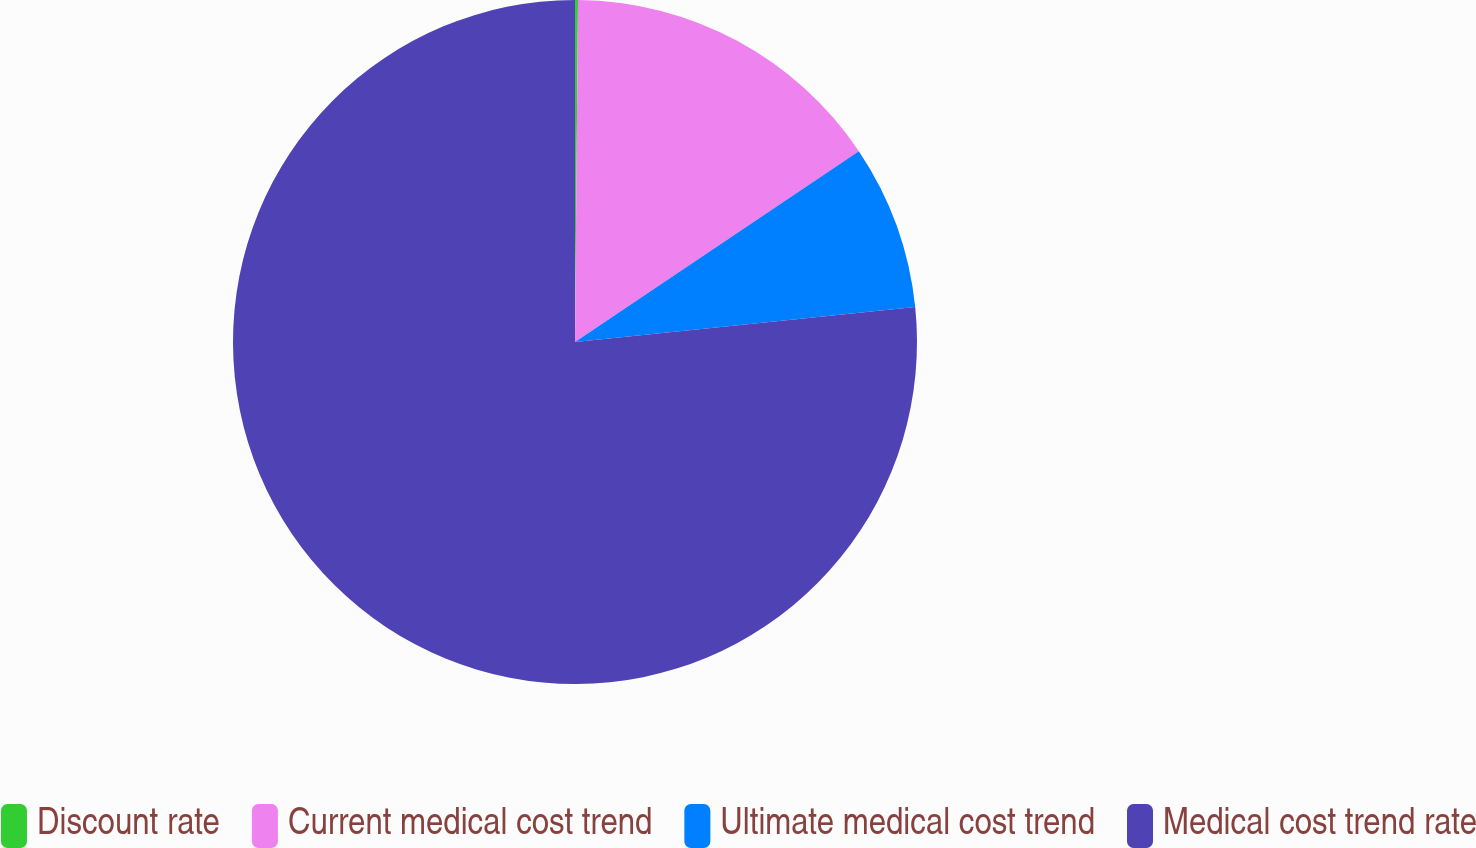Convert chart to OTSL. <chart><loc_0><loc_0><loc_500><loc_500><pie_chart><fcel>Discount rate<fcel>Current medical cost trend<fcel>Ultimate medical cost trend<fcel>Medical cost trend rate<nl><fcel>0.14%<fcel>15.44%<fcel>7.79%<fcel>76.63%<nl></chart> 